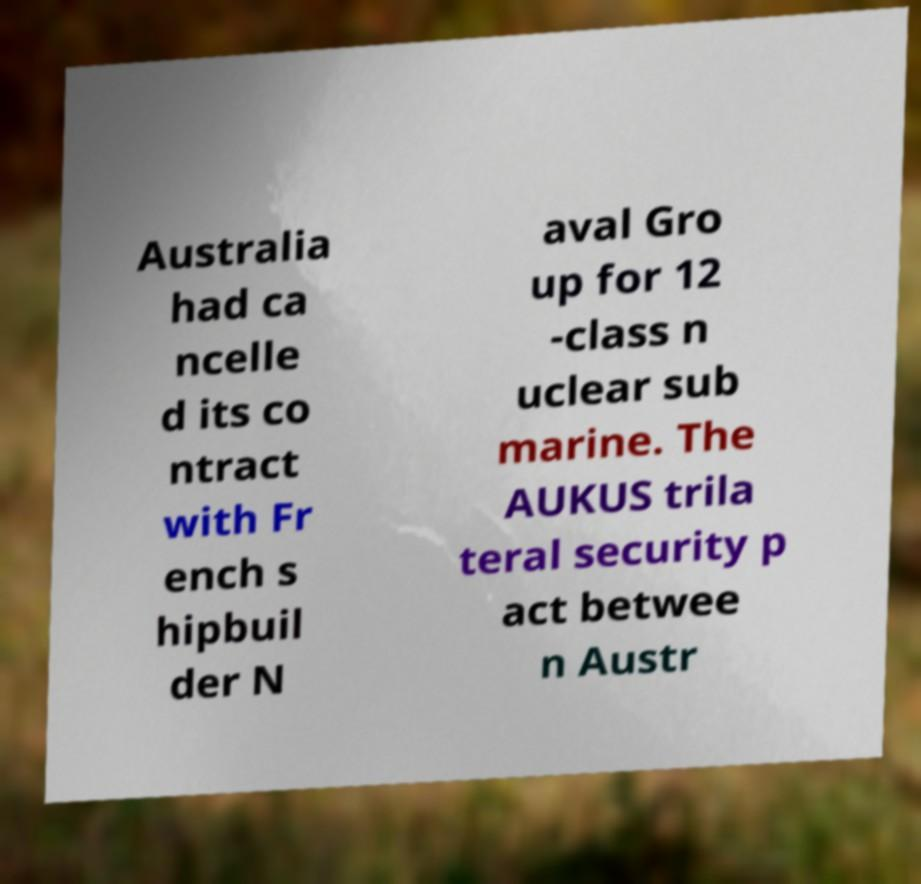I need the written content from this picture converted into text. Can you do that? Australia had ca ncelle d its co ntract with Fr ench s hipbuil der N aval Gro up for 12 -class n uclear sub marine. The AUKUS trila teral security p act betwee n Austr 